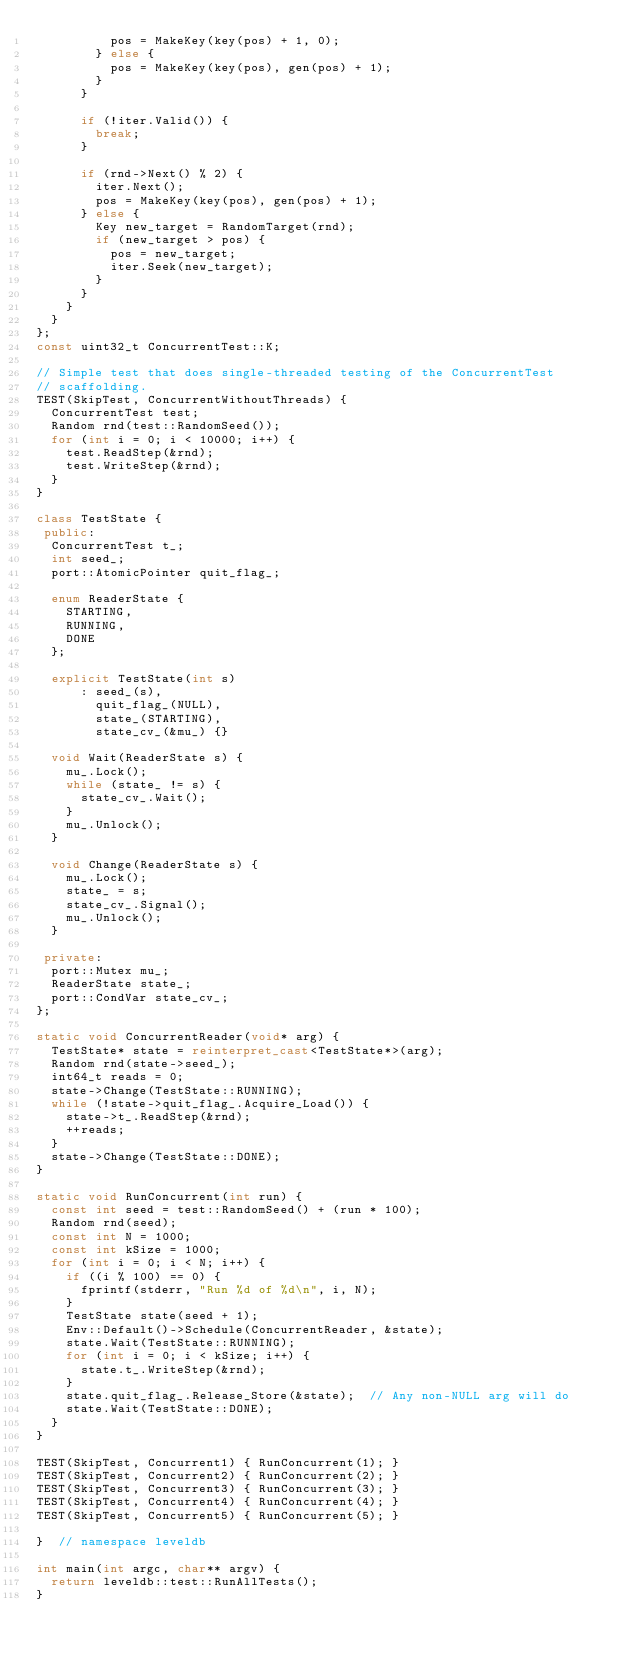<code> <loc_0><loc_0><loc_500><loc_500><_C++_>          pos = MakeKey(key(pos) + 1, 0);
        } else {
          pos = MakeKey(key(pos), gen(pos) + 1);
        }
      }

      if (!iter.Valid()) {
        break;
      }

      if (rnd->Next() % 2) {
        iter.Next();
        pos = MakeKey(key(pos), gen(pos) + 1);
      } else {
        Key new_target = RandomTarget(rnd);
        if (new_target > pos) {
          pos = new_target;
          iter.Seek(new_target);
        }
      }
    }
  }
};
const uint32_t ConcurrentTest::K;

// Simple test that does single-threaded testing of the ConcurrentTest
// scaffolding.
TEST(SkipTest, ConcurrentWithoutThreads) {
  ConcurrentTest test;
  Random rnd(test::RandomSeed());
  for (int i = 0; i < 10000; i++) {
    test.ReadStep(&rnd);
    test.WriteStep(&rnd);
  }
}

class TestState {
 public:
  ConcurrentTest t_;
  int seed_;
  port::AtomicPointer quit_flag_;

  enum ReaderState {
    STARTING,
    RUNNING,
    DONE
  };

  explicit TestState(int s)
      : seed_(s),
        quit_flag_(NULL),
        state_(STARTING),
        state_cv_(&mu_) {}

  void Wait(ReaderState s) {
    mu_.Lock();
    while (state_ != s) {
      state_cv_.Wait();
    }
    mu_.Unlock();
  }

  void Change(ReaderState s) {
    mu_.Lock();
    state_ = s;
    state_cv_.Signal();
    mu_.Unlock();
  }

 private:
  port::Mutex mu_;
  ReaderState state_;
  port::CondVar state_cv_;
};

static void ConcurrentReader(void* arg) {
  TestState* state = reinterpret_cast<TestState*>(arg);
  Random rnd(state->seed_);
  int64_t reads = 0;
  state->Change(TestState::RUNNING);
  while (!state->quit_flag_.Acquire_Load()) {
    state->t_.ReadStep(&rnd);
    ++reads;
  }
  state->Change(TestState::DONE);
}

static void RunConcurrent(int run) {
  const int seed = test::RandomSeed() + (run * 100);
  Random rnd(seed);
  const int N = 1000;
  const int kSize = 1000;
  for (int i = 0; i < N; i++) {
    if ((i % 100) == 0) {
      fprintf(stderr, "Run %d of %d\n", i, N);
    }
    TestState state(seed + 1);
    Env::Default()->Schedule(ConcurrentReader, &state);
    state.Wait(TestState::RUNNING);
    for (int i = 0; i < kSize; i++) {
      state.t_.WriteStep(&rnd);
    }
    state.quit_flag_.Release_Store(&state);  // Any non-NULL arg will do
    state.Wait(TestState::DONE);
  }
}

TEST(SkipTest, Concurrent1) { RunConcurrent(1); }
TEST(SkipTest, Concurrent2) { RunConcurrent(2); }
TEST(SkipTest, Concurrent3) { RunConcurrent(3); }
TEST(SkipTest, Concurrent4) { RunConcurrent(4); }
TEST(SkipTest, Concurrent5) { RunConcurrent(5); }

}  // namespace leveldb

int main(int argc, char** argv) {
  return leveldb::test::RunAllTests();
}
</code> 